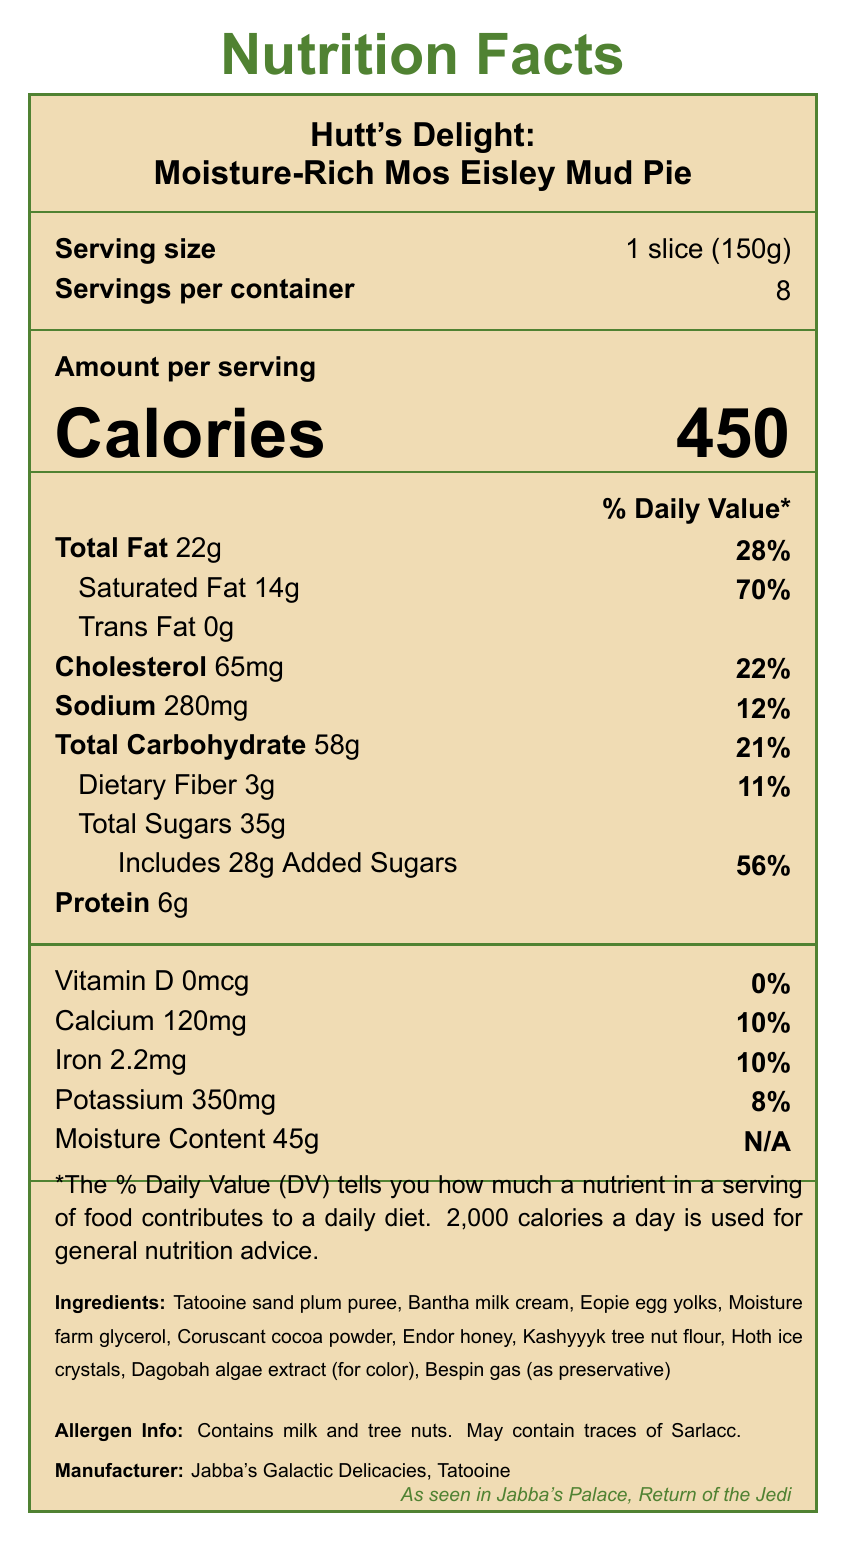what is the serving size? The serving size is listed as "1 slice (150g)" in the Nutrition Facts.
Answer: 1 slice (150g) how many servings are there per container? The document indicates that there are 8 servings per container.
Answer: 8 what is the calorie count per serving? The calorie count per serving is shown prominently as "Calories 450."
Answer: 450 what is the total fat content per serving? The total fat content per serving is listed as "Total Fat 22g."
Answer: 22g what percentage of the daily value does the saturated fat represent? The saturated fat content is 14g, which is 70% of the daily value.
Answer: 70% how much sodium is in one serving? The sodium content per serving is specified as "Sodium 280mg."
Answer: 280mg which nutrient has added sugars listed, and what is its amount? The document shows "Total Sugars 35g" and includes "28g Added Sugars."
Answer: Total Sugars with 28g added sugars what is the amount of dietary fiber per serving and its daily value percentage? The dietary fiber content is listed as "Dietary Fiber 3g" which is 11% of the daily value.
Answer: 3g, 11% does this dessert contain tree nuts? The allergen information states it contains tree nuts.
Answer: Yes what is the fun fact mentioned in the document? The fun fact states that the delicacy helped sustain Luke Skywalker during his moisture farming days.
Answer: This delicacy helped sustain Luke Skywalker during his moisture farming days! which ingredient gives color to the dessert? A. Tatooine sand plum puree B. Dagobah algae extract C. Endor honey D. Hoth ice crystals The document lists "Dagobah algae extract (for color)" among the ingredients.
Answer: B. Dagobah algae extract what is the total carbohydrate content in one serving? A. 21g B. 45g C. 58g D. 35g The total carbohydrate content per serving is "Total Carbohydrate 58g."
Answer: C. 58g which ingredient acts as the preservative in this dessert? A. Dagobah algae extract B. Endor honey C. Bespin gas D. Hoth ice crystals Bespin gas is mentioned as the preservative among the ingredients.
Answer: C. Bespin gas does this dessert contain any vitamin D? The vitamin D content is listed as "0mcg," which corresponds to 0% of the daily value.
Answer: No what is the total moisture content per serving? The document lists the moisture content as "Moisture Content 45g."
Answer: 45g describe the overall content of the nutrition facts label The document thoroughly lists nutritional information about the product. It includes detailed breakdowns of key nutrients, allergen warnings, ingredient lists, and some fun historical tidbits related to the Star Wars universe.
Answer: The nutrition facts label provides detailed information about the Moisture-Rich Mos Eisley Mud Pie, revealing serving size, servings per container, calorie count, and nutritional values like total fat, saturated fat, cholesterol, sodium, total carbohydrates, dietary fiber, total sugars, added sugars, protein, and moisture content. Additionally, it includes allergen information, ingredients, a fun fact, movie trivia, and mentions the manufacturer. what is the exact percentage of the daily value for potassium per serving? The amount of potassium per serving is 350mg, which constitutes 8% of the daily value.
Answer: 8% what is the total sugar amount in the whole container? The label provides the total sugars per serving but does not directly state the total sugars for the entire container.
Answer: Cannot be determined 